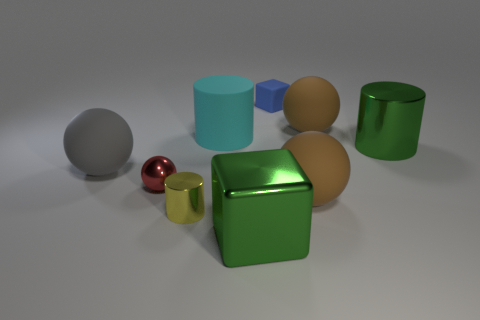Is there a shiny thing of the same color as the large shiny cylinder? Yes, there is a smaller, shiny object of the same vibrant green color as the large shiny cylinder toward the front of the image. 